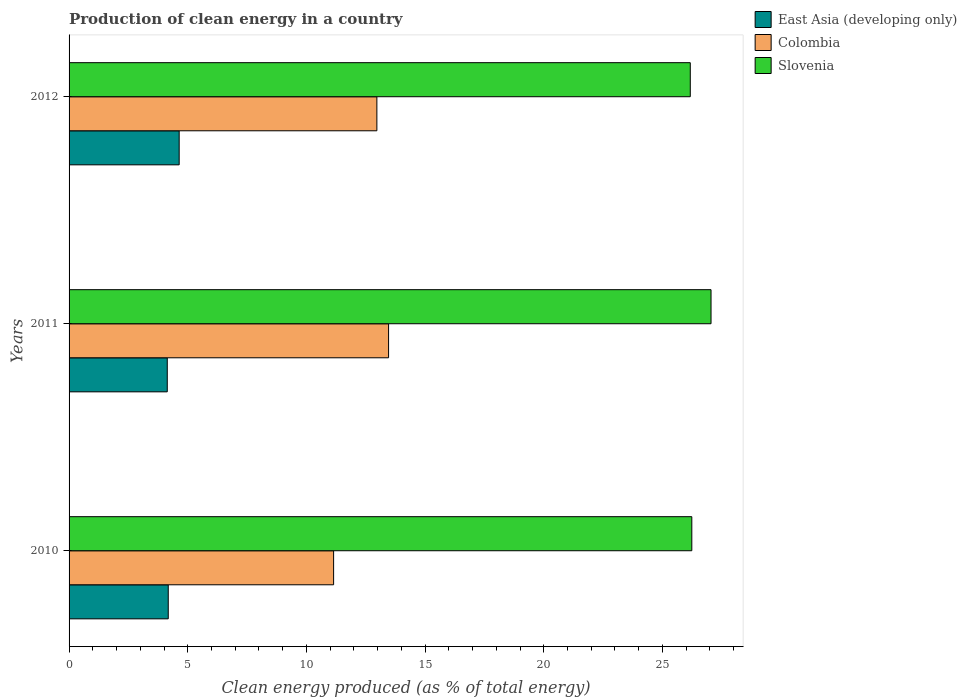In how many cases, is the number of bars for a given year not equal to the number of legend labels?
Give a very brief answer. 0. What is the percentage of clean energy produced in Slovenia in 2010?
Provide a succinct answer. 26.24. Across all years, what is the maximum percentage of clean energy produced in Slovenia?
Make the answer very short. 27.05. Across all years, what is the minimum percentage of clean energy produced in Slovenia?
Offer a very short reply. 26.17. In which year was the percentage of clean energy produced in East Asia (developing only) maximum?
Your response must be concise. 2012. In which year was the percentage of clean energy produced in Colombia minimum?
Offer a terse response. 2010. What is the total percentage of clean energy produced in East Asia (developing only) in the graph?
Make the answer very short. 12.95. What is the difference between the percentage of clean energy produced in East Asia (developing only) in 2010 and that in 2012?
Provide a short and direct response. -0.46. What is the difference between the percentage of clean energy produced in Colombia in 2011 and the percentage of clean energy produced in Slovenia in 2012?
Give a very brief answer. -12.71. What is the average percentage of clean energy produced in Slovenia per year?
Your response must be concise. 26.49. In the year 2012, what is the difference between the percentage of clean energy produced in Colombia and percentage of clean energy produced in Slovenia?
Your response must be concise. -13.21. What is the ratio of the percentage of clean energy produced in East Asia (developing only) in 2010 to that in 2011?
Your response must be concise. 1.01. Is the percentage of clean energy produced in East Asia (developing only) in 2011 less than that in 2012?
Your response must be concise. Yes. Is the difference between the percentage of clean energy produced in Colombia in 2011 and 2012 greater than the difference between the percentage of clean energy produced in Slovenia in 2011 and 2012?
Your answer should be very brief. No. What is the difference between the highest and the second highest percentage of clean energy produced in East Asia (developing only)?
Offer a terse response. 0.46. What is the difference between the highest and the lowest percentage of clean energy produced in Colombia?
Make the answer very short. 2.32. Is the sum of the percentage of clean energy produced in Colombia in 2011 and 2012 greater than the maximum percentage of clean energy produced in East Asia (developing only) across all years?
Provide a short and direct response. Yes. What does the 2nd bar from the top in 2010 represents?
Offer a terse response. Colombia. What does the 1st bar from the bottom in 2011 represents?
Provide a succinct answer. East Asia (developing only). Is it the case that in every year, the sum of the percentage of clean energy produced in East Asia (developing only) and percentage of clean energy produced in Slovenia is greater than the percentage of clean energy produced in Colombia?
Your answer should be compact. Yes. How many bars are there?
Give a very brief answer. 9. Are all the bars in the graph horizontal?
Give a very brief answer. Yes. How many years are there in the graph?
Your answer should be compact. 3. What is the difference between two consecutive major ticks on the X-axis?
Ensure brevity in your answer.  5. Are the values on the major ticks of X-axis written in scientific E-notation?
Make the answer very short. No. Where does the legend appear in the graph?
Your answer should be compact. Top right. How many legend labels are there?
Your answer should be very brief. 3. What is the title of the graph?
Provide a short and direct response. Production of clean energy in a country. Does "Bangladesh" appear as one of the legend labels in the graph?
Offer a very short reply. No. What is the label or title of the X-axis?
Your answer should be compact. Clean energy produced (as % of total energy). What is the Clean energy produced (as % of total energy) in East Asia (developing only) in 2010?
Provide a succinct answer. 4.18. What is the Clean energy produced (as % of total energy) of Colombia in 2010?
Provide a succinct answer. 11.15. What is the Clean energy produced (as % of total energy) in Slovenia in 2010?
Make the answer very short. 26.24. What is the Clean energy produced (as % of total energy) in East Asia (developing only) in 2011?
Your answer should be compact. 4.14. What is the Clean energy produced (as % of total energy) of Colombia in 2011?
Offer a very short reply. 13.46. What is the Clean energy produced (as % of total energy) of Slovenia in 2011?
Your answer should be compact. 27.05. What is the Clean energy produced (as % of total energy) of East Asia (developing only) in 2012?
Offer a very short reply. 4.64. What is the Clean energy produced (as % of total energy) of Colombia in 2012?
Ensure brevity in your answer.  12.97. What is the Clean energy produced (as % of total energy) in Slovenia in 2012?
Give a very brief answer. 26.17. Across all years, what is the maximum Clean energy produced (as % of total energy) in East Asia (developing only)?
Give a very brief answer. 4.64. Across all years, what is the maximum Clean energy produced (as % of total energy) in Colombia?
Your answer should be very brief. 13.46. Across all years, what is the maximum Clean energy produced (as % of total energy) in Slovenia?
Ensure brevity in your answer.  27.05. Across all years, what is the minimum Clean energy produced (as % of total energy) of East Asia (developing only)?
Offer a terse response. 4.14. Across all years, what is the minimum Clean energy produced (as % of total energy) in Colombia?
Offer a very short reply. 11.15. Across all years, what is the minimum Clean energy produced (as % of total energy) in Slovenia?
Provide a short and direct response. 26.17. What is the total Clean energy produced (as % of total energy) of East Asia (developing only) in the graph?
Provide a short and direct response. 12.95. What is the total Clean energy produced (as % of total energy) of Colombia in the graph?
Offer a terse response. 37.58. What is the total Clean energy produced (as % of total energy) of Slovenia in the graph?
Your response must be concise. 79.46. What is the difference between the Clean energy produced (as % of total energy) in East Asia (developing only) in 2010 and that in 2011?
Keep it short and to the point. 0.04. What is the difference between the Clean energy produced (as % of total energy) of Colombia in 2010 and that in 2011?
Keep it short and to the point. -2.32. What is the difference between the Clean energy produced (as % of total energy) of Slovenia in 2010 and that in 2011?
Your response must be concise. -0.81. What is the difference between the Clean energy produced (as % of total energy) in East Asia (developing only) in 2010 and that in 2012?
Offer a very short reply. -0.46. What is the difference between the Clean energy produced (as % of total energy) of Colombia in 2010 and that in 2012?
Provide a succinct answer. -1.82. What is the difference between the Clean energy produced (as % of total energy) of Slovenia in 2010 and that in 2012?
Give a very brief answer. 0.06. What is the difference between the Clean energy produced (as % of total energy) of East Asia (developing only) in 2011 and that in 2012?
Offer a terse response. -0.5. What is the difference between the Clean energy produced (as % of total energy) in Colombia in 2011 and that in 2012?
Provide a short and direct response. 0.49. What is the difference between the Clean energy produced (as % of total energy) of Slovenia in 2011 and that in 2012?
Keep it short and to the point. 0.87. What is the difference between the Clean energy produced (as % of total energy) in East Asia (developing only) in 2010 and the Clean energy produced (as % of total energy) in Colombia in 2011?
Your answer should be compact. -9.28. What is the difference between the Clean energy produced (as % of total energy) of East Asia (developing only) in 2010 and the Clean energy produced (as % of total energy) of Slovenia in 2011?
Provide a succinct answer. -22.87. What is the difference between the Clean energy produced (as % of total energy) of Colombia in 2010 and the Clean energy produced (as % of total energy) of Slovenia in 2011?
Give a very brief answer. -15.9. What is the difference between the Clean energy produced (as % of total energy) in East Asia (developing only) in 2010 and the Clean energy produced (as % of total energy) in Colombia in 2012?
Offer a very short reply. -8.79. What is the difference between the Clean energy produced (as % of total energy) of East Asia (developing only) in 2010 and the Clean energy produced (as % of total energy) of Slovenia in 2012?
Your response must be concise. -22. What is the difference between the Clean energy produced (as % of total energy) of Colombia in 2010 and the Clean energy produced (as % of total energy) of Slovenia in 2012?
Give a very brief answer. -15.03. What is the difference between the Clean energy produced (as % of total energy) of East Asia (developing only) in 2011 and the Clean energy produced (as % of total energy) of Colombia in 2012?
Your answer should be compact. -8.83. What is the difference between the Clean energy produced (as % of total energy) in East Asia (developing only) in 2011 and the Clean energy produced (as % of total energy) in Slovenia in 2012?
Your answer should be compact. -22.04. What is the difference between the Clean energy produced (as % of total energy) in Colombia in 2011 and the Clean energy produced (as % of total energy) in Slovenia in 2012?
Your answer should be very brief. -12.71. What is the average Clean energy produced (as % of total energy) in East Asia (developing only) per year?
Your response must be concise. 4.32. What is the average Clean energy produced (as % of total energy) in Colombia per year?
Offer a very short reply. 12.53. What is the average Clean energy produced (as % of total energy) of Slovenia per year?
Make the answer very short. 26.49. In the year 2010, what is the difference between the Clean energy produced (as % of total energy) of East Asia (developing only) and Clean energy produced (as % of total energy) of Colombia?
Offer a terse response. -6.97. In the year 2010, what is the difference between the Clean energy produced (as % of total energy) in East Asia (developing only) and Clean energy produced (as % of total energy) in Slovenia?
Ensure brevity in your answer.  -22.06. In the year 2010, what is the difference between the Clean energy produced (as % of total energy) of Colombia and Clean energy produced (as % of total energy) of Slovenia?
Ensure brevity in your answer.  -15.09. In the year 2011, what is the difference between the Clean energy produced (as % of total energy) in East Asia (developing only) and Clean energy produced (as % of total energy) in Colombia?
Your response must be concise. -9.32. In the year 2011, what is the difference between the Clean energy produced (as % of total energy) of East Asia (developing only) and Clean energy produced (as % of total energy) of Slovenia?
Ensure brevity in your answer.  -22.91. In the year 2011, what is the difference between the Clean energy produced (as % of total energy) of Colombia and Clean energy produced (as % of total energy) of Slovenia?
Give a very brief answer. -13.59. In the year 2012, what is the difference between the Clean energy produced (as % of total energy) of East Asia (developing only) and Clean energy produced (as % of total energy) of Colombia?
Give a very brief answer. -8.33. In the year 2012, what is the difference between the Clean energy produced (as % of total energy) of East Asia (developing only) and Clean energy produced (as % of total energy) of Slovenia?
Offer a very short reply. -21.53. In the year 2012, what is the difference between the Clean energy produced (as % of total energy) in Colombia and Clean energy produced (as % of total energy) in Slovenia?
Offer a very short reply. -13.21. What is the ratio of the Clean energy produced (as % of total energy) of Colombia in 2010 to that in 2011?
Your answer should be compact. 0.83. What is the ratio of the Clean energy produced (as % of total energy) of Slovenia in 2010 to that in 2011?
Your answer should be compact. 0.97. What is the ratio of the Clean energy produced (as % of total energy) of East Asia (developing only) in 2010 to that in 2012?
Keep it short and to the point. 0.9. What is the ratio of the Clean energy produced (as % of total energy) in Colombia in 2010 to that in 2012?
Provide a short and direct response. 0.86. What is the ratio of the Clean energy produced (as % of total energy) of Slovenia in 2010 to that in 2012?
Give a very brief answer. 1. What is the ratio of the Clean energy produced (as % of total energy) of East Asia (developing only) in 2011 to that in 2012?
Your response must be concise. 0.89. What is the ratio of the Clean energy produced (as % of total energy) in Colombia in 2011 to that in 2012?
Offer a terse response. 1.04. What is the ratio of the Clean energy produced (as % of total energy) of Slovenia in 2011 to that in 2012?
Your answer should be very brief. 1.03. What is the difference between the highest and the second highest Clean energy produced (as % of total energy) in East Asia (developing only)?
Your response must be concise. 0.46. What is the difference between the highest and the second highest Clean energy produced (as % of total energy) of Colombia?
Ensure brevity in your answer.  0.49. What is the difference between the highest and the second highest Clean energy produced (as % of total energy) of Slovenia?
Give a very brief answer. 0.81. What is the difference between the highest and the lowest Clean energy produced (as % of total energy) of East Asia (developing only)?
Your response must be concise. 0.5. What is the difference between the highest and the lowest Clean energy produced (as % of total energy) in Colombia?
Your answer should be very brief. 2.32. What is the difference between the highest and the lowest Clean energy produced (as % of total energy) in Slovenia?
Make the answer very short. 0.87. 